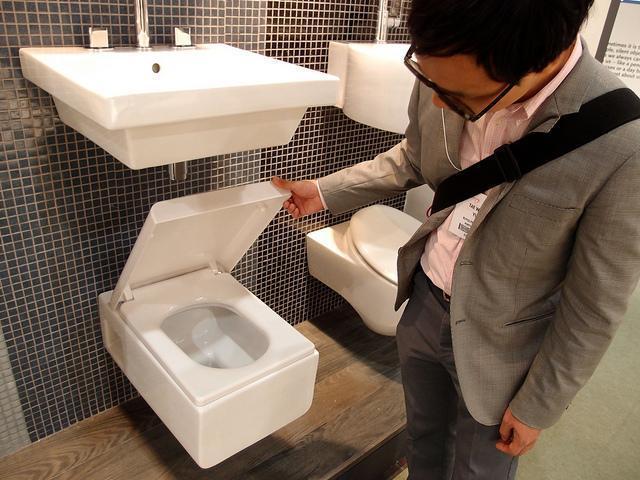How many toilets are there?
Give a very brief answer. 2. How many sinks are there?
Give a very brief answer. 2. How many sheep are facing forward?
Give a very brief answer. 0. 